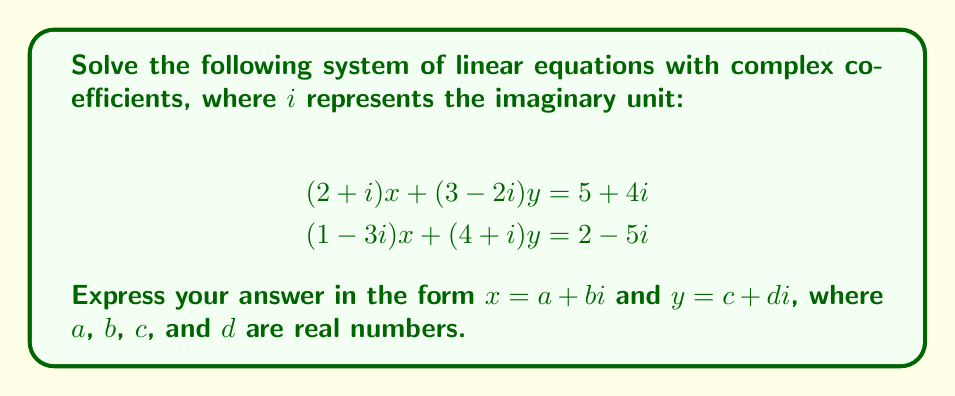Show me your answer to this math problem. Let's solve this system using the substitution method:

1) First, let's isolate $x$ in the first equation:
   $$(2+i)x = (5+4i) - (3-2i)y$$
   $$x = \frac{(5+4i) - (3-2i)y}{2+i}$$

2) Multiply both numerator and denominator by the complex conjugate of the denominator $(2-i)$:
   $$x = \frac{((5+4i) - (3-2i)y)(2-i)}{(2+i)(2-i)} = \frac{((5+4i) - (3-2i)y)(2-i)}{5}$$

3) Expand the numerator:
   $$x = \frac{(10-5i+8i+4i^2) - (6-3i-2iy+i^2y)}{5}$$
   $$x = \frac{(6-3i+8i) - (6-3i-2iy-y)}{5}$$
   $$x = \frac{5i+2iy+y}{5} = \frac{y(2i+1)+5i}{5}$$

4) Substitute this expression for $x$ into the second equation:
   $$(1-3i)(\frac{y(2i+1)+5i}{5}) + (4+i)y = 2-5i$$

5) Multiply out the brackets:
   $$\frac{(1-3i)(y(2i+1)+5i)}{5} + (4+i)y = 2-5i$$
   $$\frac{y(2i+1-6i-3)+5i-15i^2}{5} + (4+i)y = 2-5i$$
   $$\frac{y(-4i-2)+20i}{5} + (4+i)y = 2-5i$$

6) Multiply both sides by 5:
   $$y(-4i-2)+20i + (20+5i)y = 10-25i$$
   $$y(-4i-2+20+5i)+20i = 10-25i$$
   $$y(16+i)+20i = 10-25i$$

7) Equate real and imaginary parts:
   Real: $16y = 10$
   Imaginary: $y+20 = -25$

8) From the real part: $y = \frac{10}{16} = \frac{5}{8}$

9) Substitute this back into the expression for $x$:
   $$x = \frac{(\frac{5}{8})(2i+1)+5i}{5} = \frac{5i+\frac{5}{8}+40i}{40} = \frac{45i+5}{40} = \frac{9i+1}{8}$$

Therefore, $x = \frac{1}{8} + \frac{9}{8}i$ and $y = \frac{5}{8}$.
Answer: $x = \frac{1}{8} + \frac{9}{8}i$, $y = \frac{5}{8}$ 